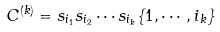<formula> <loc_0><loc_0><loc_500><loc_500>C ^ { ( k ) } = s _ { i _ { 1 } } s _ { i _ { 2 } } \cdots s _ { i _ { k } } \{ 1 , \cdots , i _ { k } \}</formula> 